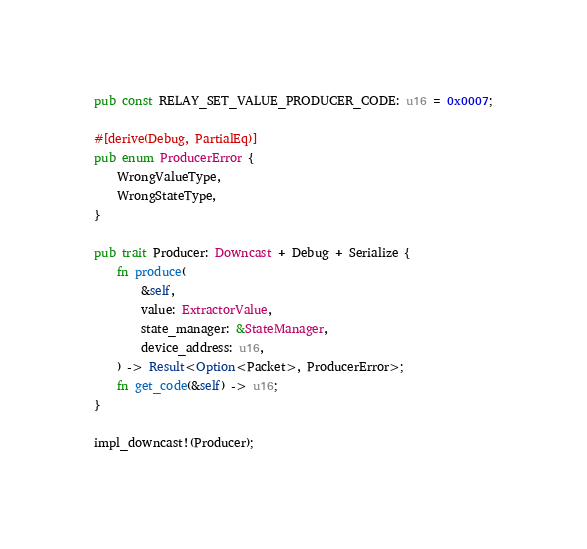<code> <loc_0><loc_0><loc_500><loc_500><_Rust_>pub const RELAY_SET_VALUE_PRODUCER_CODE: u16 = 0x0007;

#[derive(Debug, PartialEq)]
pub enum ProducerError {
    WrongValueType,
    WrongStateType,
}

pub trait Producer: Downcast + Debug + Serialize {
    fn produce(
        &self,
        value: ExtractorValue,
        state_manager: &StateManager,
        device_address: u16,
    ) -> Result<Option<Packet>, ProducerError>;
    fn get_code(&self) -> u16;
}

impl_downcast!(Producer);
</code> 